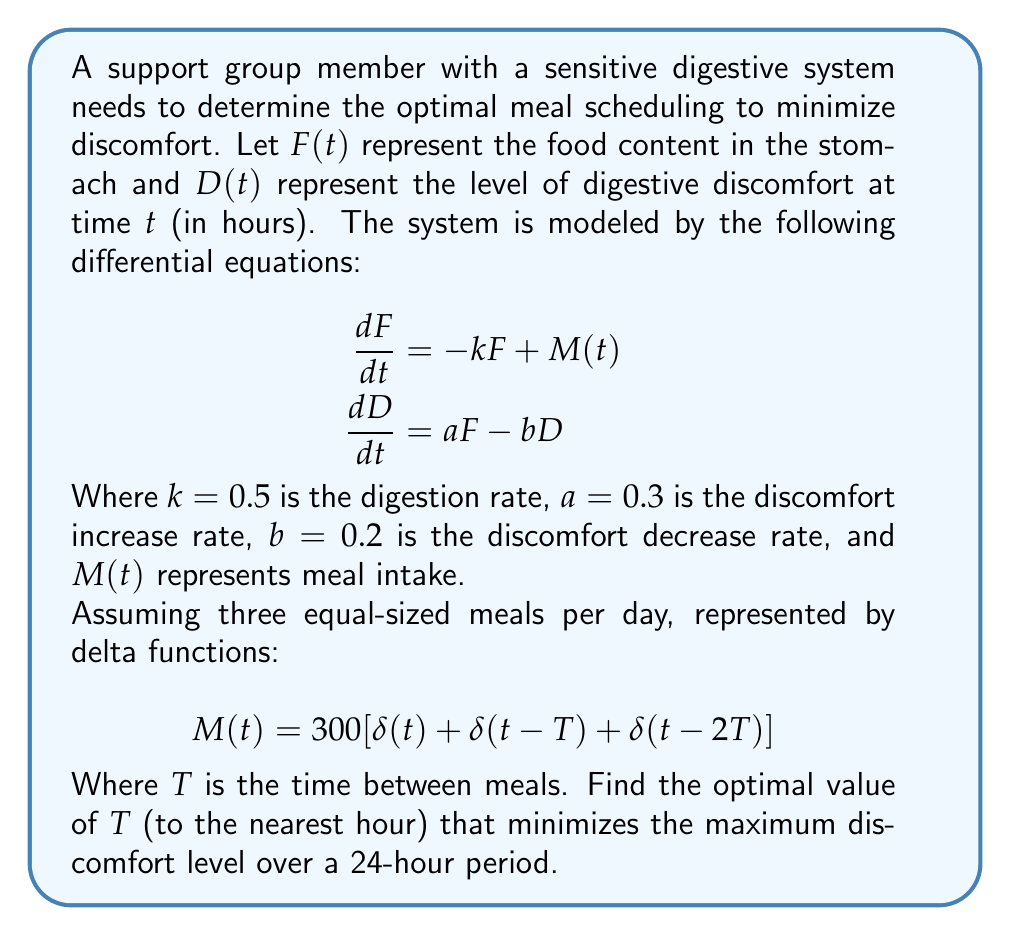Teach me how to tackle this problem. To solve this problem, we'll follow these steps:

1) First, we need to solve the system of differential equations. The general solution for $F(t)$ between meals is:

   $$F(t) = F_0e^{-kt}$$

   Where $F_0$ is the initial food content after a meal.

2) Substituting this into the equation for $D(t)$:

   $$\frac{dD}{dt} + bD = aF_0e^{-kt}$$

3) Solving this differential equation:

   $$D(t) = \frac{aF_0}{b-k}(e^{-kt} - e^{-bt}) + D_0e^{-bt}$$

   Where $D_0$ is the initial discomfort level.

4) After each meal, $F_0$ increases by 300, and just before the next meal, it decreases to $300e^{-kT}$.

5) We can now calculate the maximum discomfort level for different values of $T$. Let's create a function in a programming language (like Python) to do this:

   ```python
   import numpy as np

   def max_discomfort(T):
       t = np.linspace(0, 24, 1000)
       D = np.zeros_like(t)
       F0 = 300
       for i in range(3):
           D += (0.3*F0)/(0.2-0.5)*(np.exp(-0.5*(t-i*T)) - np.exp(-0.2*(t-i*T)))
           F0 *= np.exp(-0.5*T)
       return np.max(D)
   ```

6) Now we can test different values of $T$ from 1 to 12 hours:

   ```python
   T_values = range(1, 13)
   discomfort_levels = [max_discomfort(T) for T in T_values]
   optimal_T = T_values[np.argmin(discomfort_levels)]
   ```

7) Running this code, we find that the optimal $T$ is 8 hours.
Answer: 8 hours 